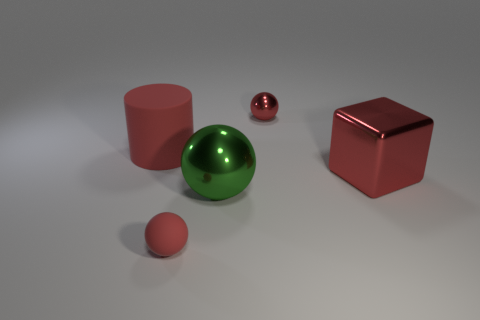The cylinder that is the same color as the metal block is what size?
Keep it short and to the point. Large. Are there any tiny objects made of the same material as the red cylinder?
Keep it short and to the point. Yes. Are the red sphere that is to the left of the big metal sphere and the red sphere behind the big block made of the same material?
Keep it short and to the point. No. How many green spheres are there?
Offer a very short reply. 1. What shape is the small thing that is in front of the large cube?
Provide a succinct answer. Sphere. What number of other things are there of the same size as the red cylinder?
Give a very brief answer. 2. There is a tiny red object behind the cube; does it have the same shape as the small thing in front of the big matte cylinder?
Provide a succinct answer. Yes. There is a green shiny sphere; what number of big red matte things are on the right side of it?
Ensure brevity in your answer.  0. The small object that is behind the cylinder is what color?
Your answer should be very brief. Red. What is the color of the large object that is the same shape as the small matte object?
Your response must be concise. Green. 